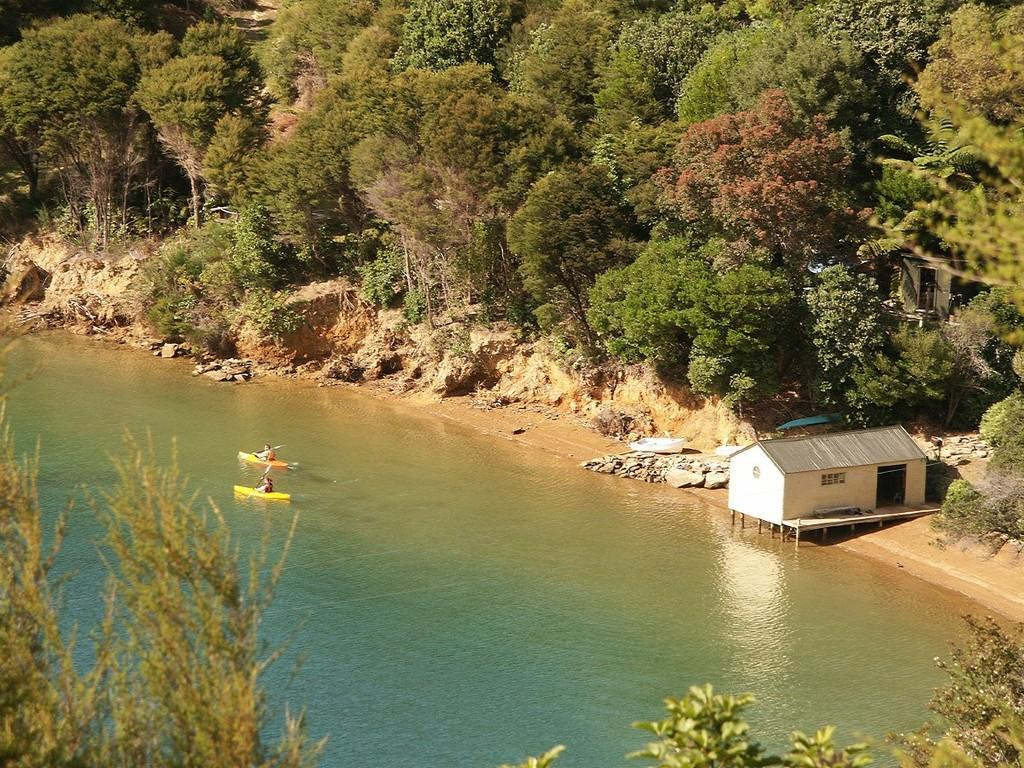What is located in the middle of the image? There is water in the middle of the image. What can be seen floating on the water? There are two boats in the water. What structure is located on the right side of the image? There is a house on the right side of the image. What type of vegetation is visible in the background of the image? There are trees in the background of the image. What type of nose can be seen on the laborer in the image? There is no laborer present in the image, and therefore no nose can be observed. 